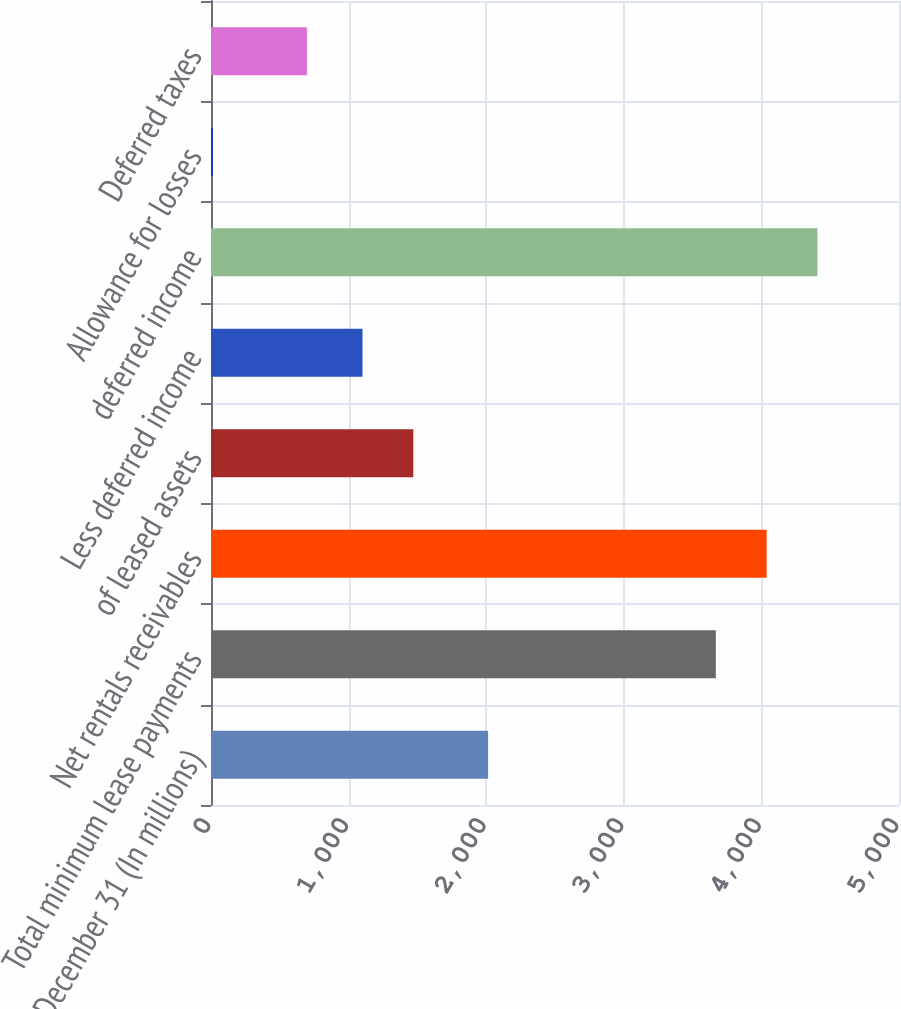<chart> <loc_0><loc_0><loc_500><loc_500><bar_chart><fcel>December 31 (In millions)<fcel>Total minimum lease payments<fcel>Net rentals receivables<fcel>of leased assets<fcel>Less deferred income<fcel>deferred income<fcel>Allowance for losses<fcel>Deferred taxes<nl><fcel>2014<fcel>3669<fcel>4038.2<fcel>1470.2<fcel>1101<fcel>4407.4<fcel>14<fcel>697<nl></chart> 